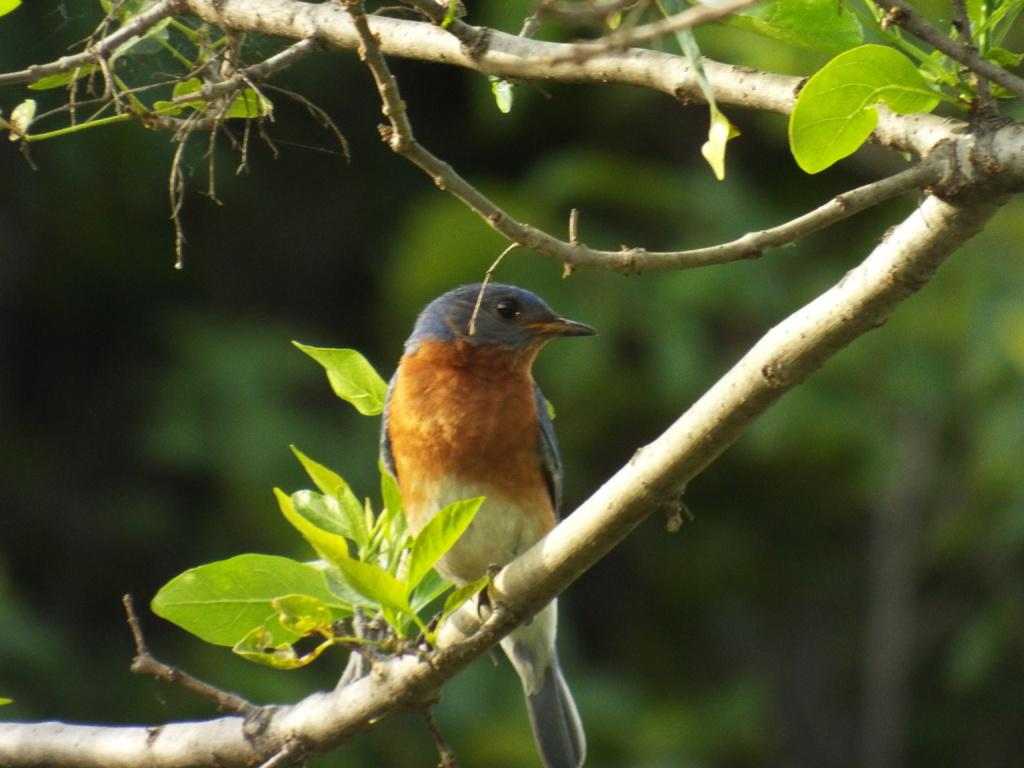What type of natural elements can be seen in the image? There are branches and leaves in the image. Is there any wildlife present in the image? Yes, there is a bird on a branch in the image. How would you describe the background of the image? The background of the image is blurred. What type of notebook is the bird using to write in the image? There is no notebook present in the image, and the bird is not shown writing. 